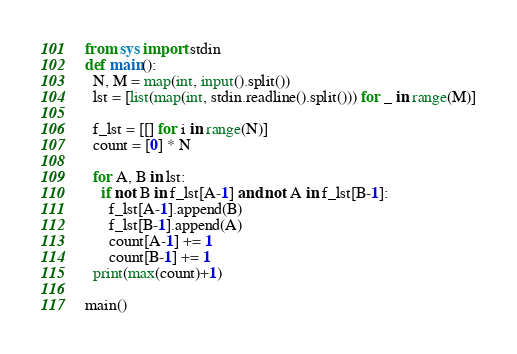<code> <loc_0><loc_0><loc_500><loc_500><_Python_>from sys import stdin
def main():
  N, M = map(int, input().split())
  lst = [list(map(int, stdin.readline().split())) for _ in range(M)]
  
  f_lst = [[] for i in range(N)]
  count = [0] * N
  
  for A, B in lst:
    if not B in f_lst[A-1] and not A in f_lst[B-1]:
      f_lst[A-1].append(B)
      f_lst[B-1].append(A)
      count[A-1] += 1
      count[B-1] += 1
  print(max(count)+1)

main()</code> 